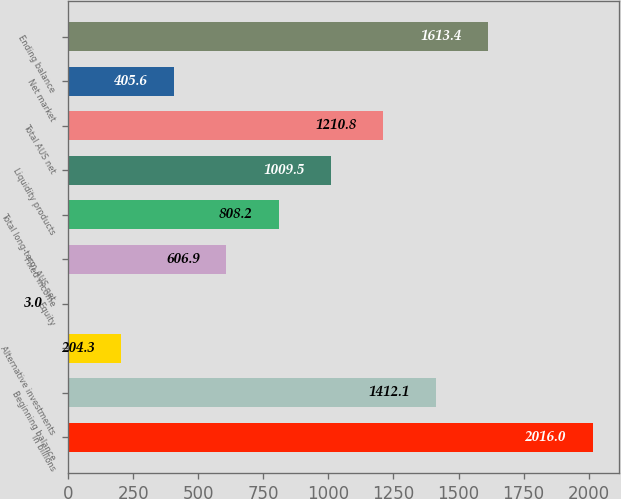Convert chart. <chart><loc_0><loc_0><loc_500><loc_500><bar_chart><fcel>in billions<fcel>Beginning balance<fcel>Alternative investments<fcel>Equity<fcel>Fixed income<fcel>Total long-term AUS net<fcel>Liquidity products<fcel>Total AUS net<fcel>Net market<fcel>Ending balance<nl><fcel>2016<fcel>1412.1<fcel>204.3<fcel>3<fcel>606.9<fcel>808.2<fcel>1009.5<fcel>1210.8<fcel>405.6<fcel>1613.4<nl></chart> 